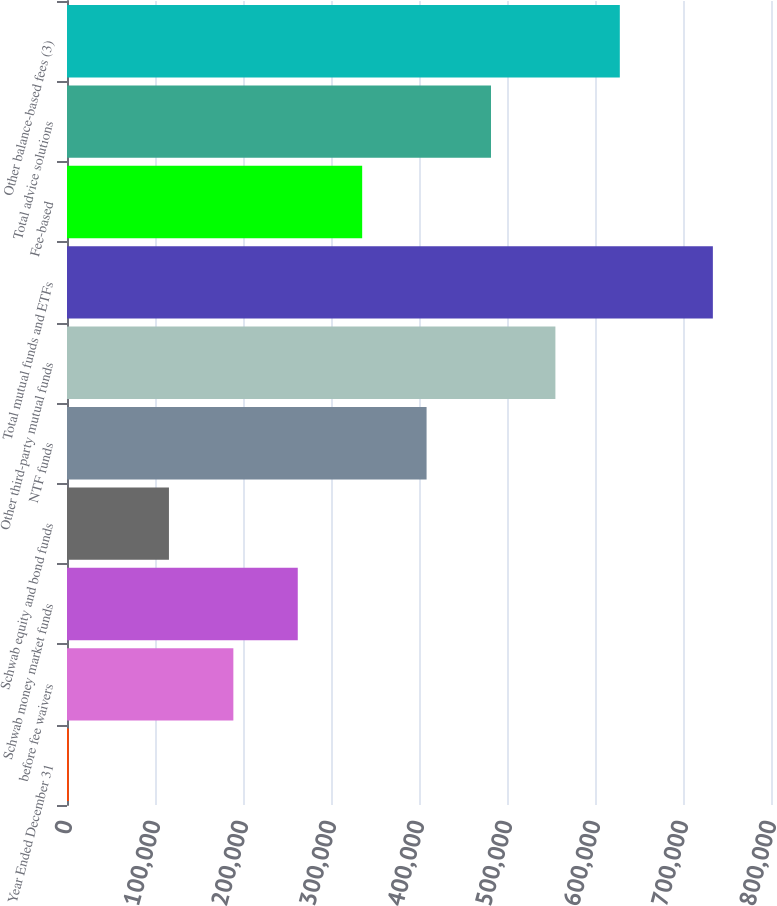<chart> <loc_0><loc_0><loc_500><loc_500><bar_chart><fcel>Year Ended December 31<fcel>before fee waivers<fcel>Schwab money market funds<fcel>Schwab equity and bond funds<fcel>NTF funds<fcel>Other third-party mutual funds<fcel>Total mutual funds and ETFs<fcel>Fee-based<fcel>Total advice solutions<fcel>Other balance-based fees (3)<nl><fcel>2016<fcel>189042<fcel>262234<fcel>115849<fcel>408619<fcel>555005<fcel>733942<fcel>335427<fcel>481812<fcel>628197<nl></chart> 